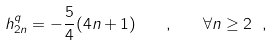<formula> <loc_0><loc_0><loc_500><loc_500>h _ { 2 n } ^ { q } = - \frac { 5 } { 4 } ( 4 n + 1 ) \quad , \quad \forall n \geq 2 \ ,</formula> 